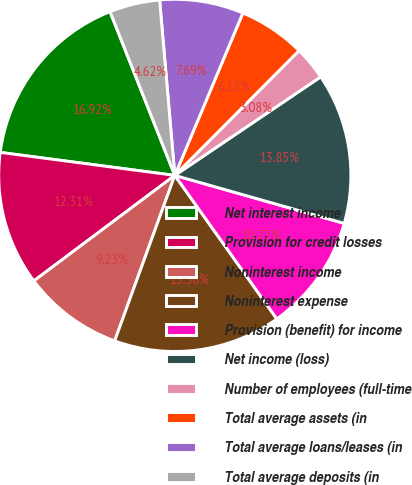Convert chart to OTSL. <chart><loc_0><loc_0><loc_500><loc_500><pie_chart><fcel>Net interest income<fcel>Provision for credit losses<fcel>Noninterest income<fcel>Noninterest expense<fcel>Provision (benefit) for income<fcel>Net income (loss)<fcel>Number of employees (full-time<fcel>Total average assets (in<fcel>Total average loans/leases (in<fcel>Total average deposits (in<nl><fcel>16.92%<fcel>12.31%<fcel>9.23%<fcel>15.38%<fcel>10.77%<fcel>13.85%<fcel>3.08%<fcel>6.15%<fcel>7.69%<fcel>4.62%<nl></chart> 